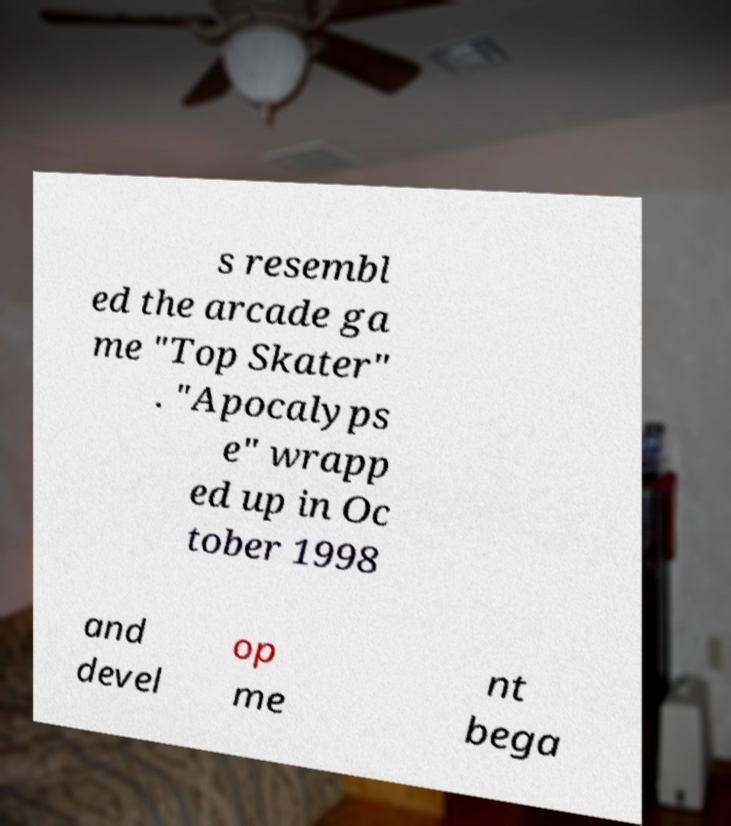Can you read and provide the text displayed in the image?This photo seems to have some interesting text. Can you extract and type it out for me? s resembl ed the arcade ga me "Top Skater" . "Apocalyps e" wrapp ed up in Oc tober 1998 and devel op me nt bega 